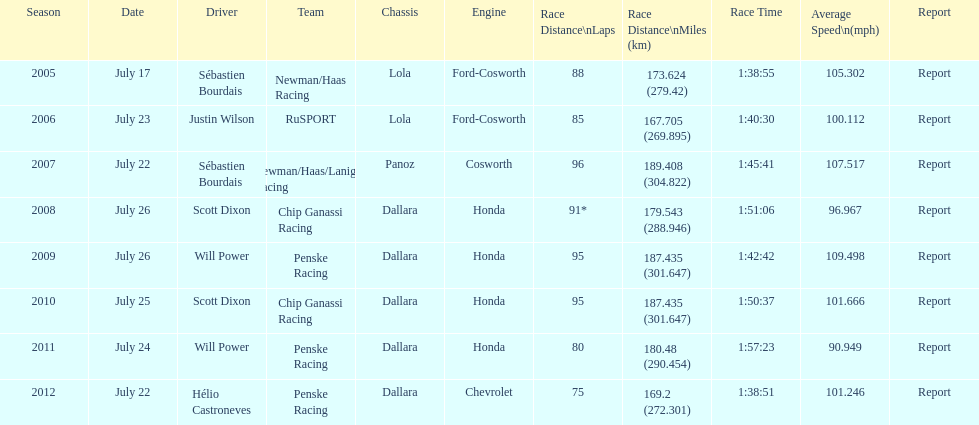How many times did sébastien bourdais win the champ car world series between 2005 and 2007? 2. 